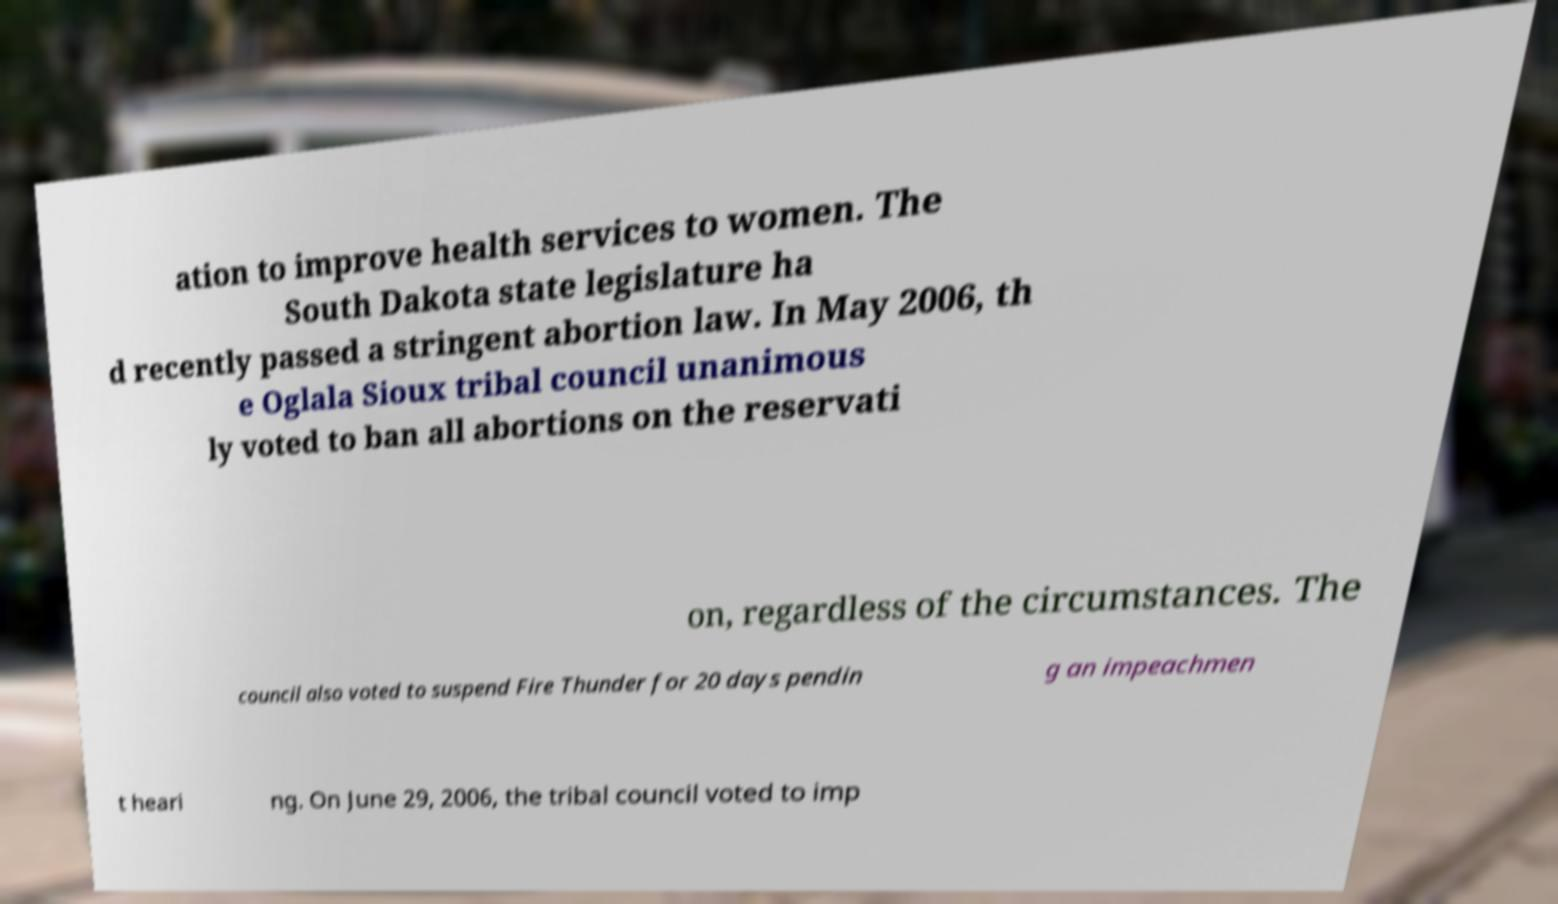For documentation purposes, I need the text within this image transcribed. Could you provide that? ation to improve health services to women. The South Dakota state legislature ha d recently passed a stringent abortion law. In May 2006, th e Oglala Sioux tribal council unanimous ly voted to ban all abortions on the reservati on, regardless of the circumstances. The council also voted to suspend Fire Thunder for 20 days pendin g an impeachmen t heari ng. On June 29, 2006, the tribal council voted to imp 